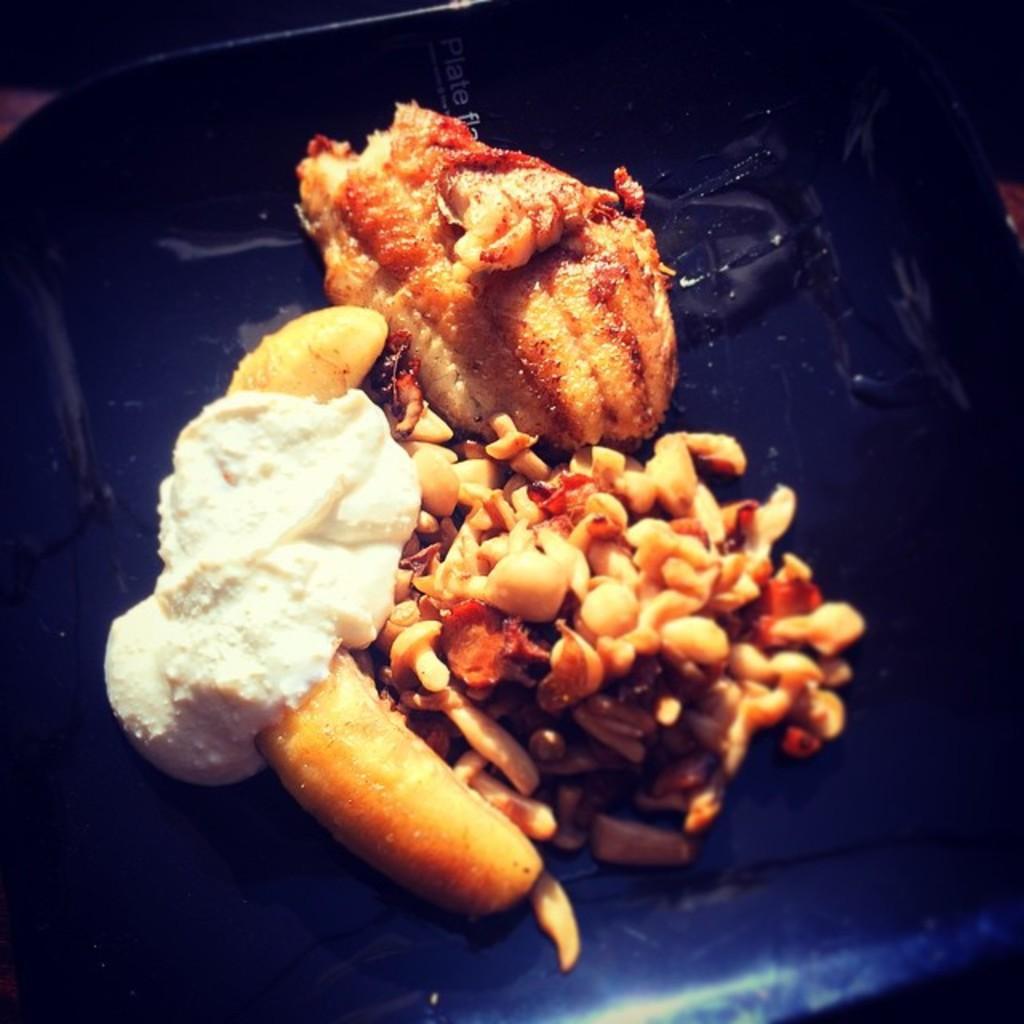Describe this image in one or two sentences. In the image there are some cooked food items and on the left side one of the food item is topped with cream. 